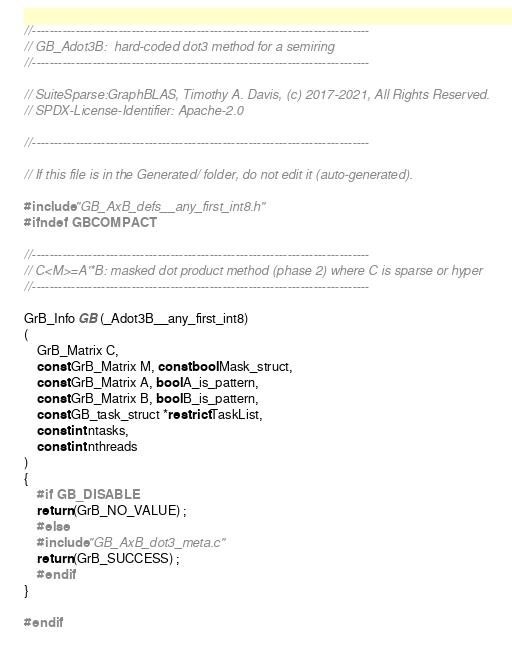Convert code to text. <code><loc_0><loc_0><loc_500><loc_500><_C_>//------------------------------------------------------------------------------
// GB_Adot3B:  hard-coded dot3 method for a semiring
//------------------------------------------------------------------------------

// SuiteSparse:GraphBLAS, Timothy A. Davis, (c) 2017-2021, All Rights Reserved.
// SPDX-License-Identifier: Apache-2.0

//------------------------------------------------------------------------------

// If this file is in the Generated/ folder, do not edit it (auto-generated).

#include "GB_AxB_defs__any_first_int8.h"
#ifndef GBCOMPACT

//------------------------------------------------------------------------------
// C<M>=A'*B: masked dot product method (phase 2) where C is sparse or hyper
//------------------------------------------------------------------------------

GrB_Info GB (_Adot3B__any_first_int8)
(
    GrB_Matrix C,
    const GrB_Matrix M, const bool Mask_struct,
    const GrB_Matrix A, bool A_is_pattern,
    const GrB_Matrix B, bool B_is_pattern,
    const GB_task_struct *restrict TaskList,
    const int ntasks,
    const int nthreads
)
{ 
    #if GB_DISABLE
    return (GrB_NO_VALUE) ;
    #else
    #include "GB_AxB_dot3_meta.c"
    return (GrB_SUCCESS) ;
    #endif
}

#endif

</code> 